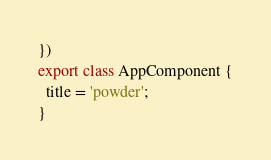Convert code to text. <code><loc_0><loc_0><loc_500><loc_500><_TypeScript_>})
export class AppComponent {
  title = 'powder';
}
</code> 